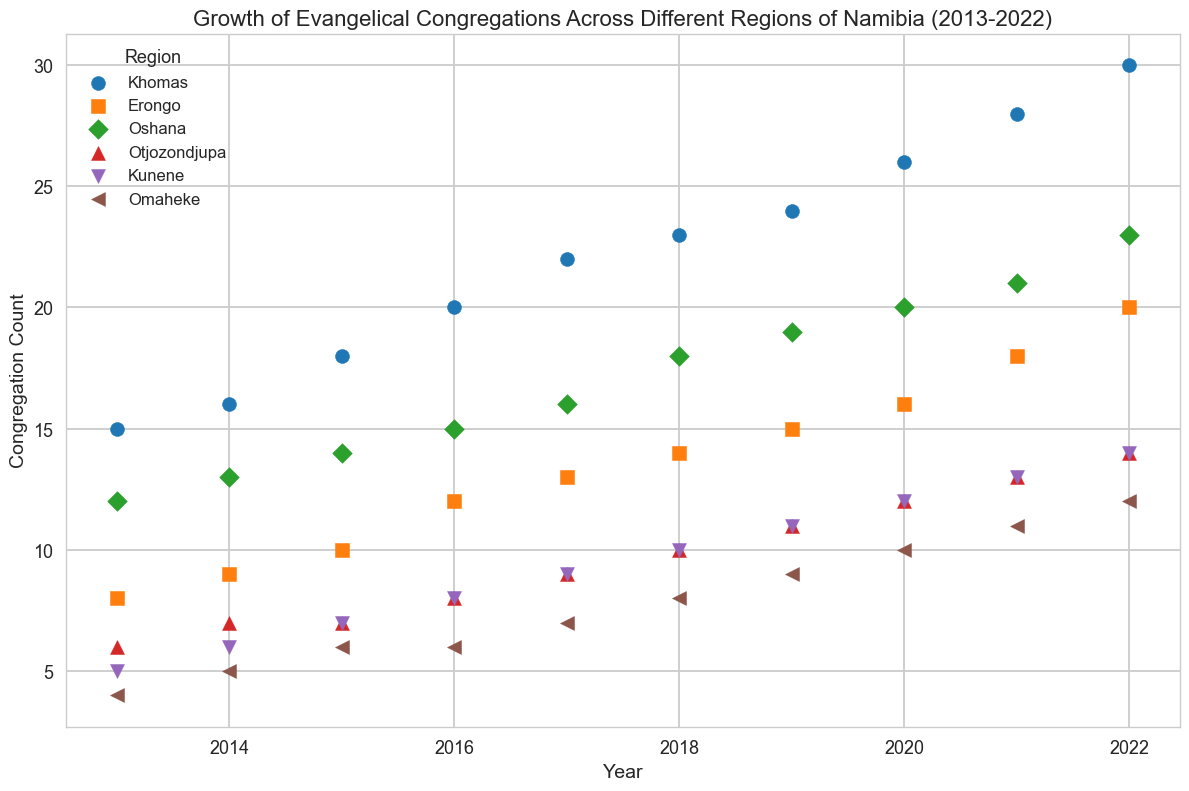What region shows the highest growth in congregations from 2013 to 2022? Compare the congregation count in 2013 and 2022 for each region. Khomas shows growth from 15 to 30, Erongo from 8 to 20, Oshana from 12 to 23, Otjozondjupa from 6 to 14, Kunene from 5 to 14, Omaheke from 4 to 12. Khomas has the highest increase (15).
Answer: Khomas Which region has the largest number of congregations in 2022? Observe the scatter plot points for the year 2022 across all regions. The highest point is for Khomas at 30.
Answer: Khomas Which region had the lowest number of congregations in 2013? Look at the scatter plot points for the year 2013 across all regions. The lowest point is for Omaheke at 4.
Answer: Omaheke Which two regions had the same number of congregations in 2022? Identify points in 2022. Otjozondjupa and Kunene both have 14 congregations.
Answer: Otjozondjupa and Kunene What is the average congregation count for Erongo from 2013 to 2022? Sum congregation counts for Erongo (8+9+10+12+13+14+15+16+18+20=135) and divide by 10.
Answer: 13.5 Which year shows the highest number of congregations in Oshana? Check points for Oshana and find the highest. In 2022, it is 23.
Answer: 2022 By how much did the number of congregations in Oshana increase from 2015 to 2019? Oshana had 14 congregations in 2015 and 19 in 2019. The increase is 19 - 14.
Answer: 5 In which region and year is the congregation growth rate the highest between consecutive years? Compute growth for consecutive years for each region, checking differences. For Kunene, from 2013 to 2014 increase by 1, 2014 to 2015 by 1, 2015 to 2016 by 1, etc. The highest is between 2016 to 2017, Khomas, with 2.
Answer: Khomas, 2016-2017 Which region has the most consistent growth in congregation count over the decade? Consistent growth means nearly uniform increments. Observing the plot, Omaheke showed uniform increments by 1 or 2 every year.
Answer: Omaheke 